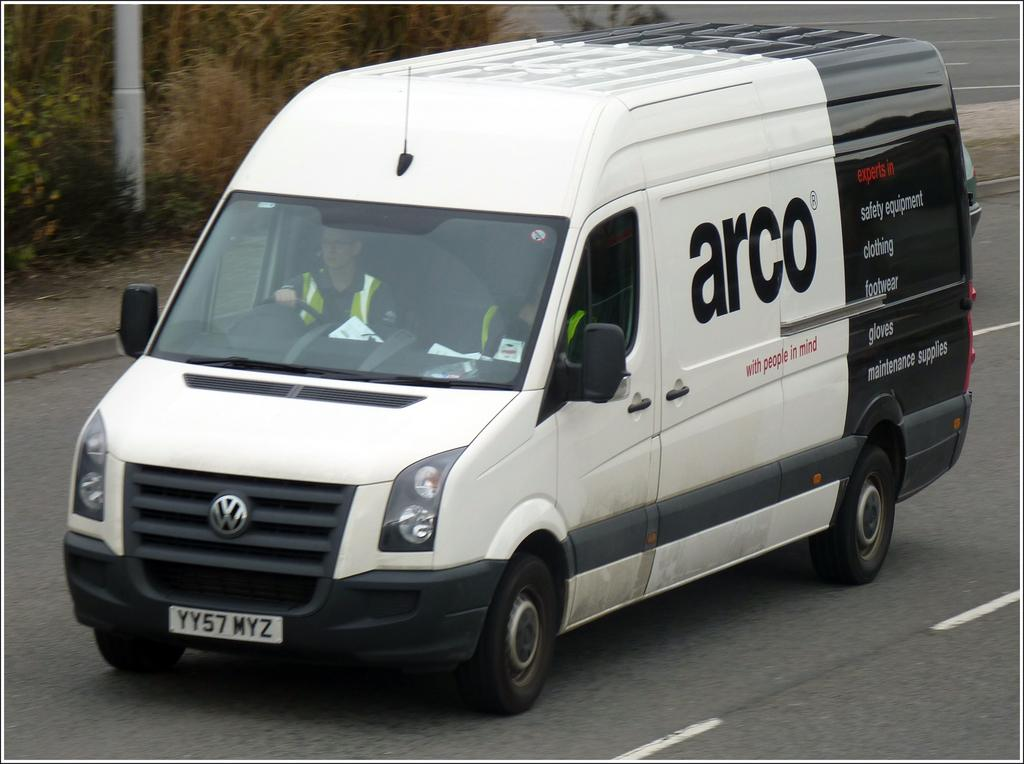<image>
Share a concise interpretation of the image provided. A black and white arco van is traveling down the road. 